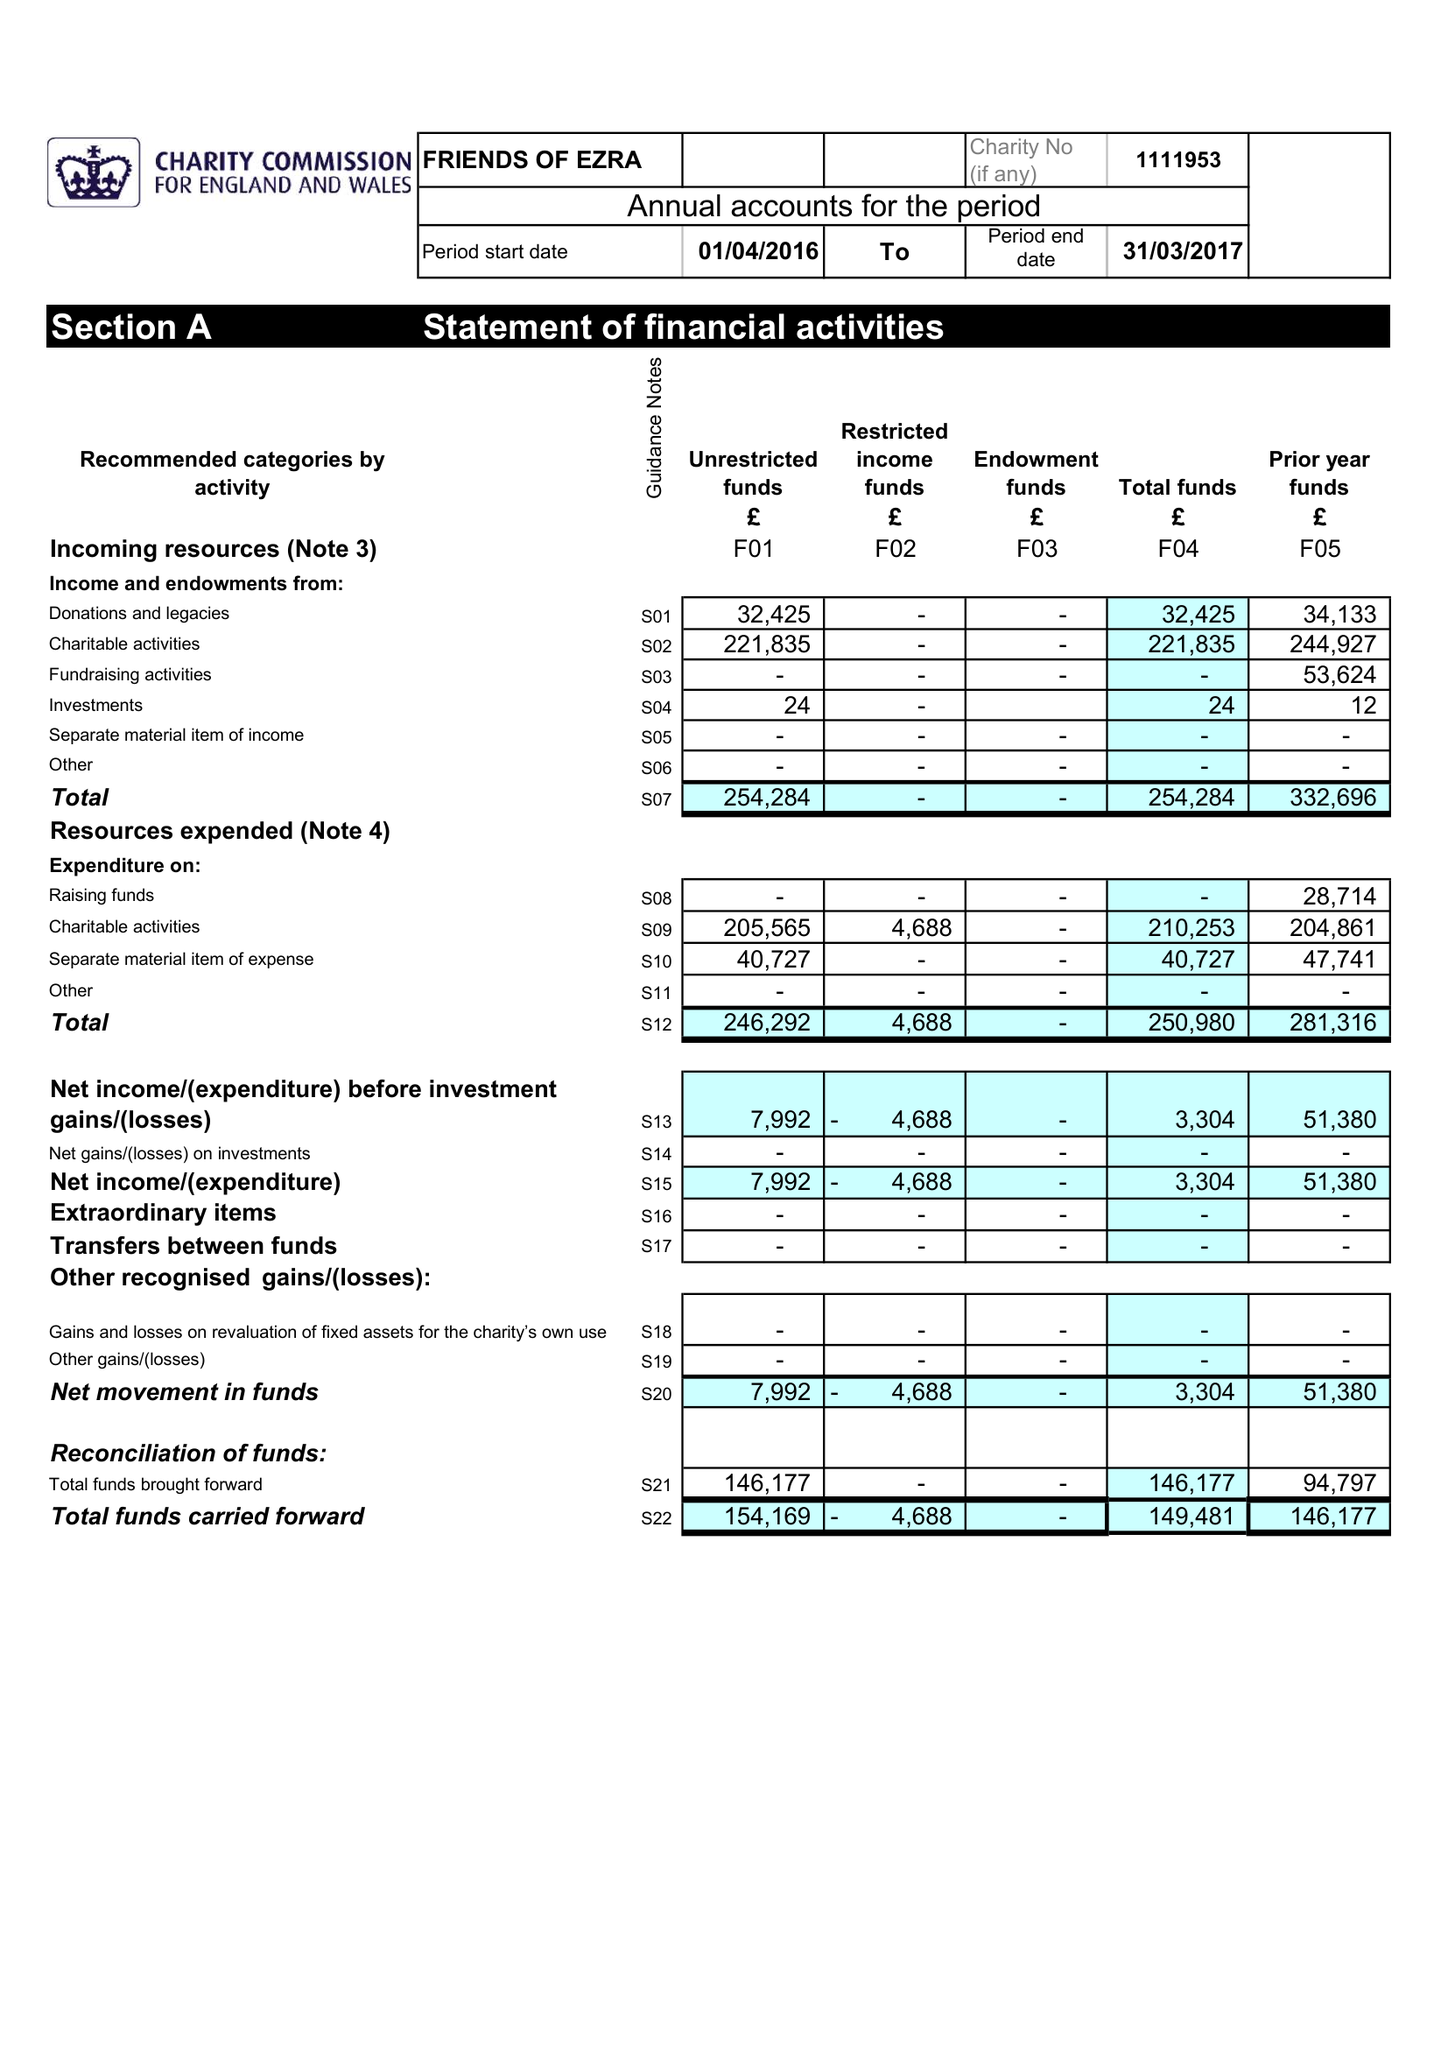What is the value for the spending_annually_in_british_pounds?
Answer the question using a single word or phrase. 246292.00 